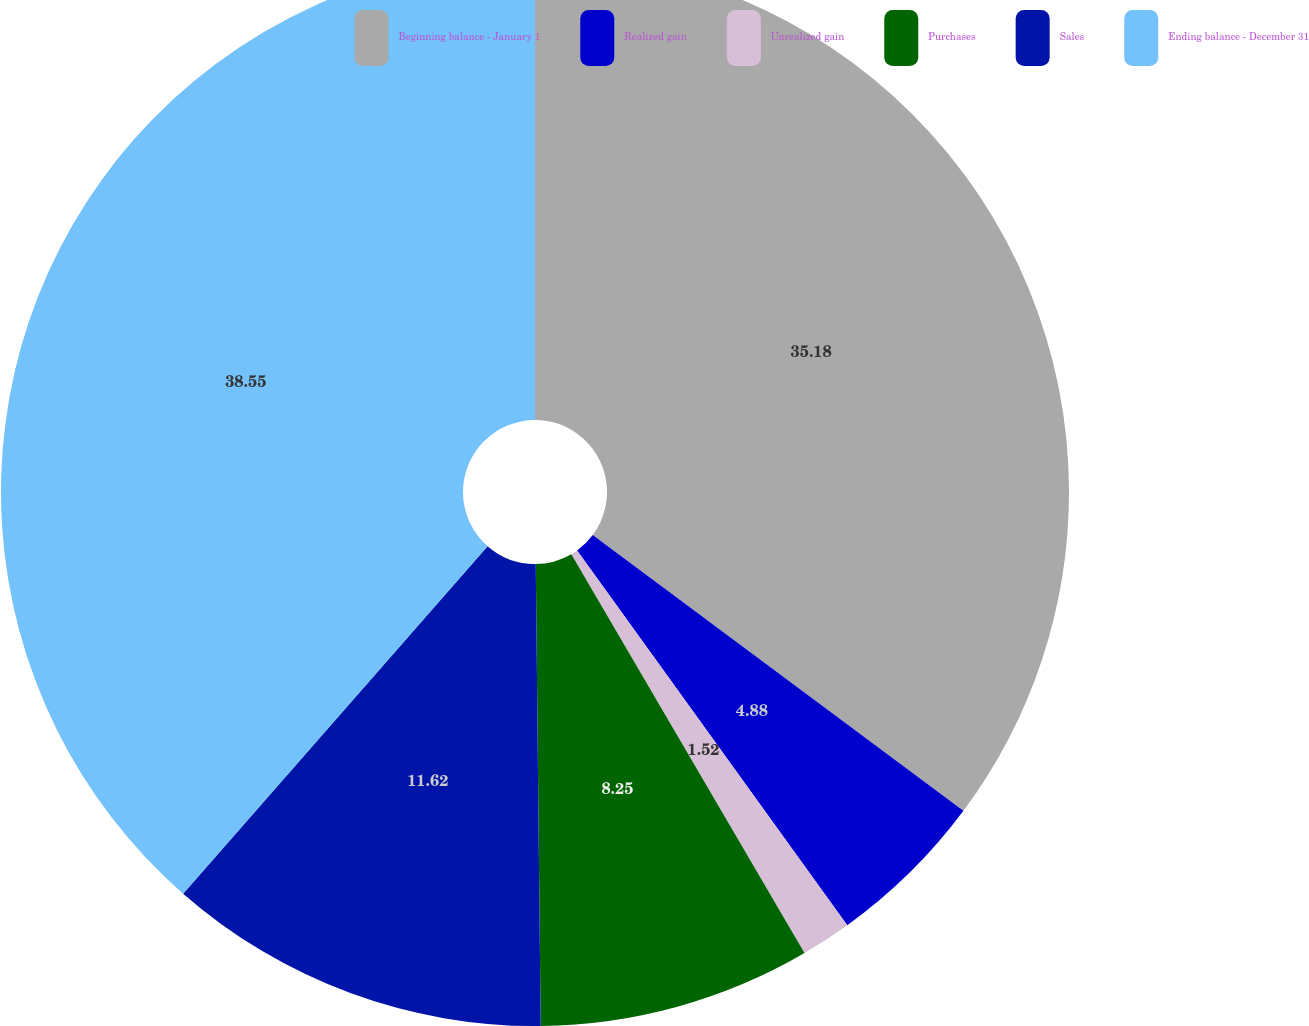<chart> <loc_0><loc_0><loc_500><loc_500><pie_chart><fcel>Beginning balance - January 1<fcel>Realized gain<fcel>Unrealized gain<fcel>Purchases<fcel>Sales<fcel>Ending balance - December 31<nl><fcel>35.18%<fcel>4.88%<fcel>1.52%<fcel>8.25%<fcel>11.62%<fcel>38.55%<nl></chart> 